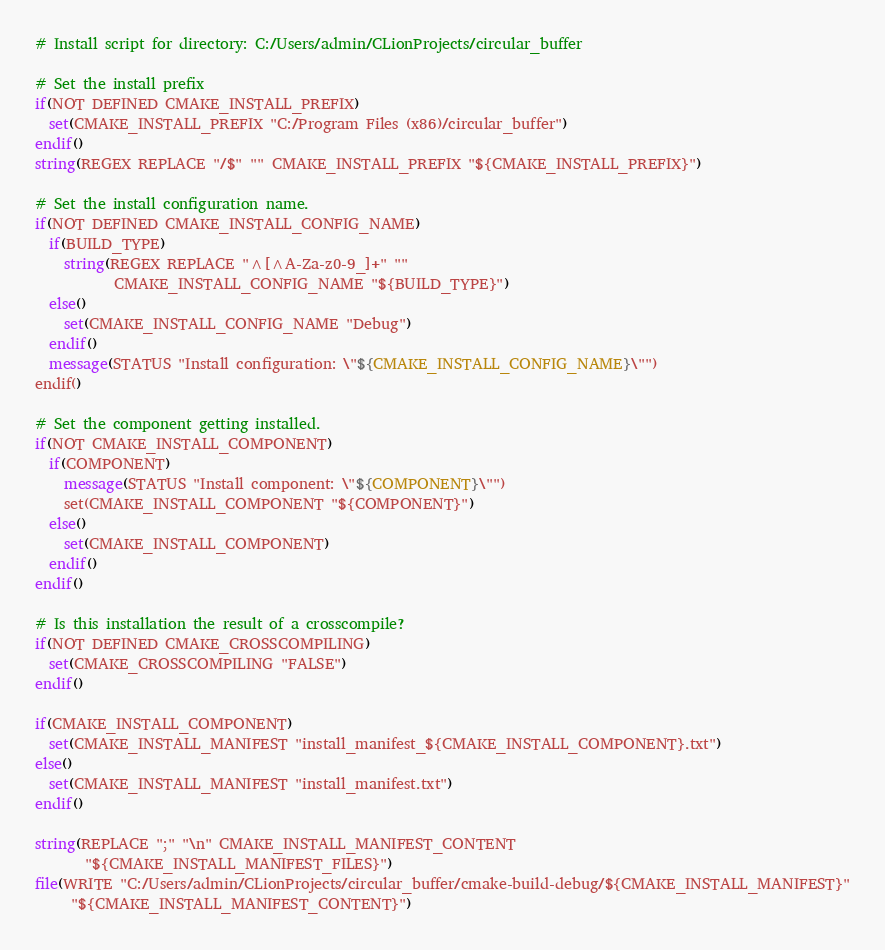<code> <loc_0><loc_0><loc_500><loc_500><_CMake_># Install script for directory: C:/Users/admin/CLionProjects/circular_buffer

# Set the install prefix
if(NOT DEFINED CMAKE_INSTALL_PREFIX)
  set(CMAKE_INSTALL_PREFIX "C:/Program Files (x86)/circular_buffer")
endif()
string(REGEX REPLACE "/$" "" CMAKE_INSTALL_PREFIX "${CMAKE_INSTALL_PREFIX}")

# Set the install configuration name.
if(NOT DEFINED CMAKE_INSTALL_CONFIG_NAME)
  if(BUILD_TYPE)
    string(REGEX REPLACE "^[^A-Za-z0-9_]+" ""
           CMAKE_INSTALL_CONFIG_NAME "${BUILD_TYPE}")
  else()
    set(CMAKE_INSTALL_CONFIG_NAME "Debug")
  endif()
  message(STATUS "Install configuration: \"${CMAKE_INSTALL_CONFIG_NAME}\"")
endif()

# Set the component getting installed.
if(NOT CMAKE_INSTALL_COMPONENT)
  if(COMPONENT)
    message(STATUS "Install component: \"${COMPONENT}\"")
    set(CMAKE_INSTALL_COMPONENT "${COMPONENT}")
  else()
    set(CMAKE_INSTALL_COMPONENT)
  endif()
endif()

# Is this installation the result of a crosscompile?
if(NOT DEFINED CMAKE_CROSSCOMPILING)
  set(CMAKE_CROSSCOMPILING "FALSE")
endif()

if(CMAKE_INSTALL_COMPONENT)
  set(CMAKE_INSTALL_MANIFEST "install_manifest_${CMAKE_INSTALL_COMPONENT}.txt")
else()
  set(CMAKE_INSTALL_MANIFEST "install_manifest.txt")
endif()

string(REPLACE ";" "\n" CMAKE_INSTALL_MANIFEST_CONTENT
       "${CMAKE_INSTALL_MANIFEST_FILES}")
file(WRITE "C:/Users/admin/CLionProjects/circular_buffer/cmake-build-debug/${CMAKE_INSTALL_MANIFEST}"
     "${CMAKE_INSTALL_MANIFEST_CONTENT}")
</code> 